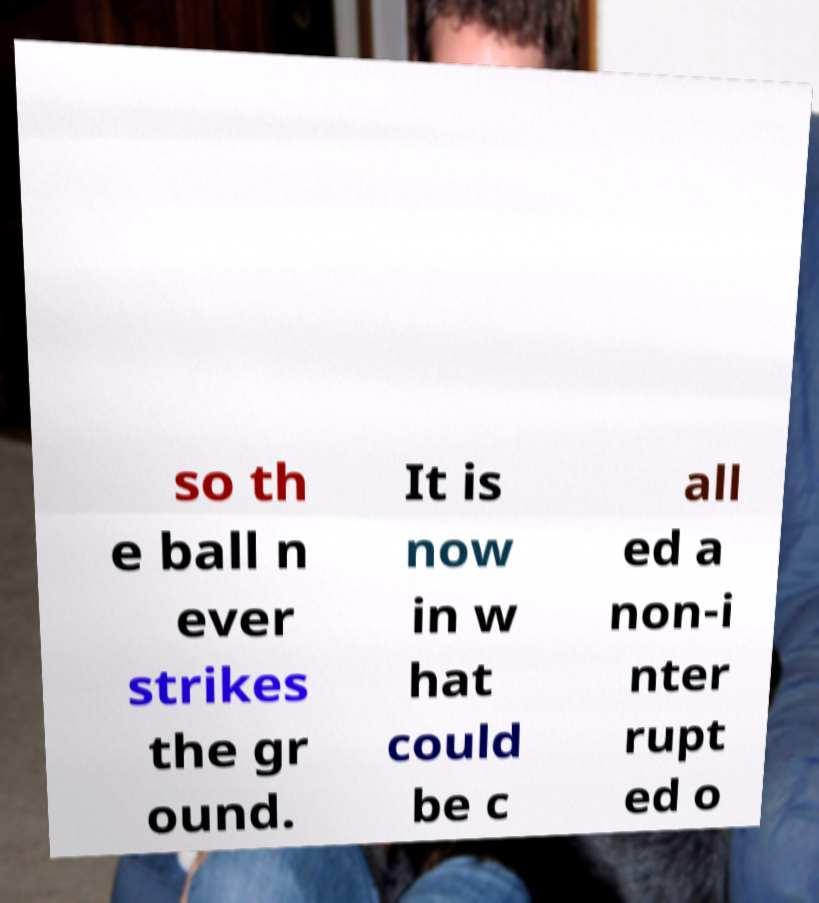For documentation purposes, I need the text within this image transcribed. Could you provide that? so th e ball n ever strikes the gr ound. It is now in w hat could be c all ed a non-i nter rupt ed o 